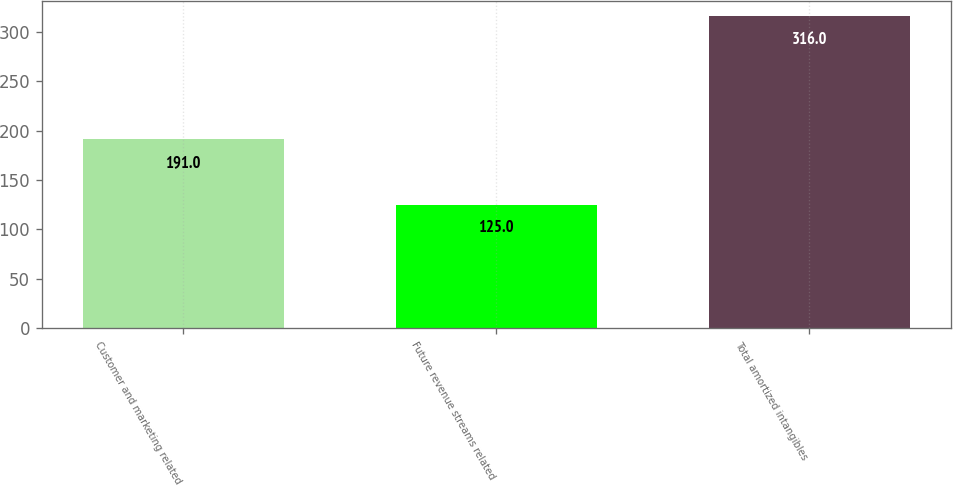<chart> <loc_0><loc_0><loc_500><loc_500><bar_chart><fcel>Customer and marketing related<fcel>Future revenue streams related<fcel>Total amortized intangibles<nl><fcel>191<fcel>125<fcel>316<nl></chart> 